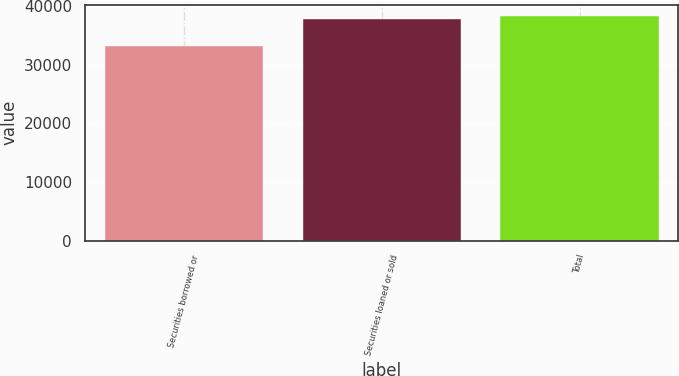<chart> <loc_0><loc_0><loc_500><loc_500><bar_chart><fcel>Securities borrowed or<fcel>Securities loaned or sold<fcel>Total<nl><fcel>33196<fcel>37809<fcel>38270.3<nl></chart> 